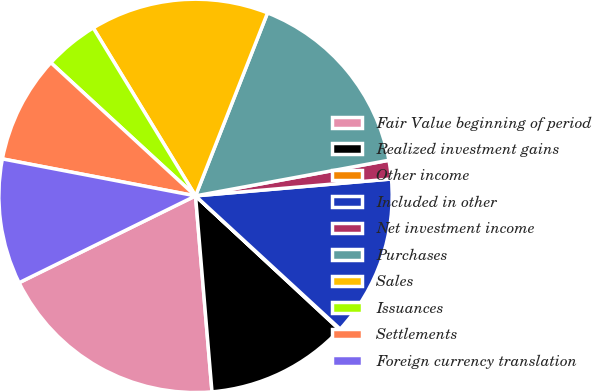Convert chart. <chart><loc_0><loc_0><loc_500><loc_500><pie_chart><fcel>Fair Value beginning of period<fcel>Realized investment gains<fcel>Other income<fcel>Included in other<fcel>Net investment income<fcel>Purchases<fcel>Sales<fcel>Issuances<fcel>Settlements<fcel>Foreign currency translation<nl><fcel>19.05%<fcel>11.75%<fcel>0.07%<fcel>13.21%<fcel>1.53%<fcel>16.13%<fcel>14.67%<fcel>4.45%<fcel>8.83%<fcel>10.29%<nl></chart> 